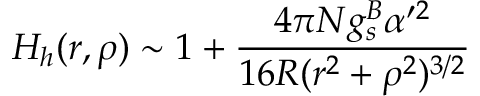Convert formula to latex. <formula><loc_0><loc_0><loc_500><loc_500>H _ { h } ( r , \rho ) \sim 1 + \frac { 4 \pi N g _ { s } ^ { B } \alpha ^ { \prime 2 } } { 1 6 R ( r ^ { 2 } + \rho ^ { 2 } ) ^ { 3 / 2 } }</formula> 